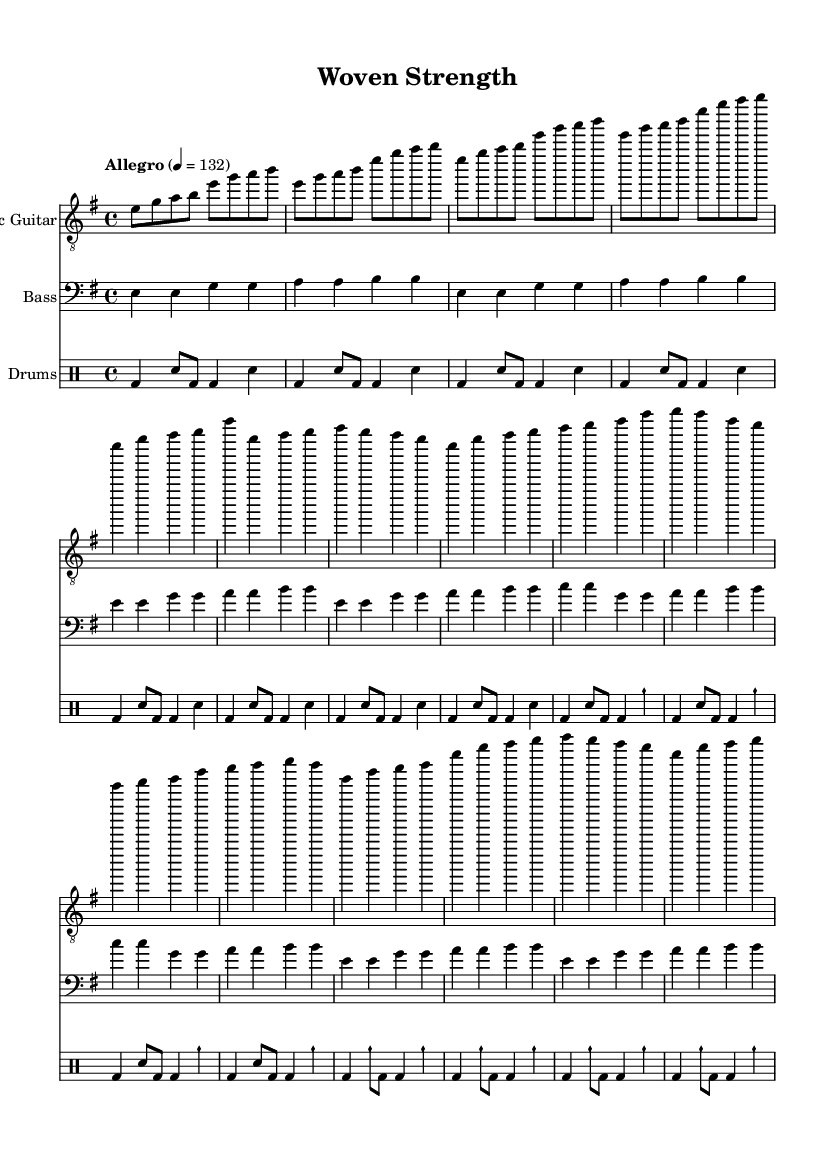What is the key signature of this music? The key signature is marked at the beginning of the score, indicating it is in E minor, which has one sharp (F#).
Answer: E minor What is the time signature of this piece? The time signature is found at the beginning of the score right after the key signature, indicated as 4/4. This means there are four beats per measure and the quarter note gets one beat.
Answer: 4/4 What is the tempo marking for this piece? The tempo marking is written as "Allegro" followed by a metronome marking of 132, which suggests a fast-paced performance.
Answer: Allegro How many measures are in the chorus section? By counting the measures specifically labeled as the chorus in the score, we see there are four measures indicated in that section.
Answer: 4 What is the primary instrument in this rock composition? The primary instrument is identified at the start of the first staff; it is designated as "Electric Guitar."
Answer: Electric Guitar Which section of the piece features the cymbal crash? The cymbal crash is specified within the drumming part, particularly in the pre-chorus and the chorus, where it is explicitly marked as "cymch."
Answer: Pre-Chorus and Chorus 